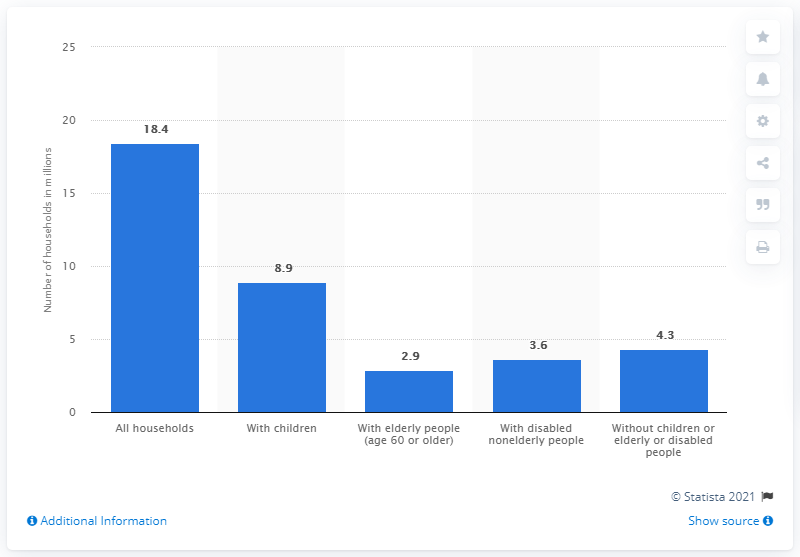Indicate a few pertinent items in this graphic. In 2010, an estimated 8.9 households with children were receiving benefits from the Supplemental Nutrition Assistance Program (SNAP). 